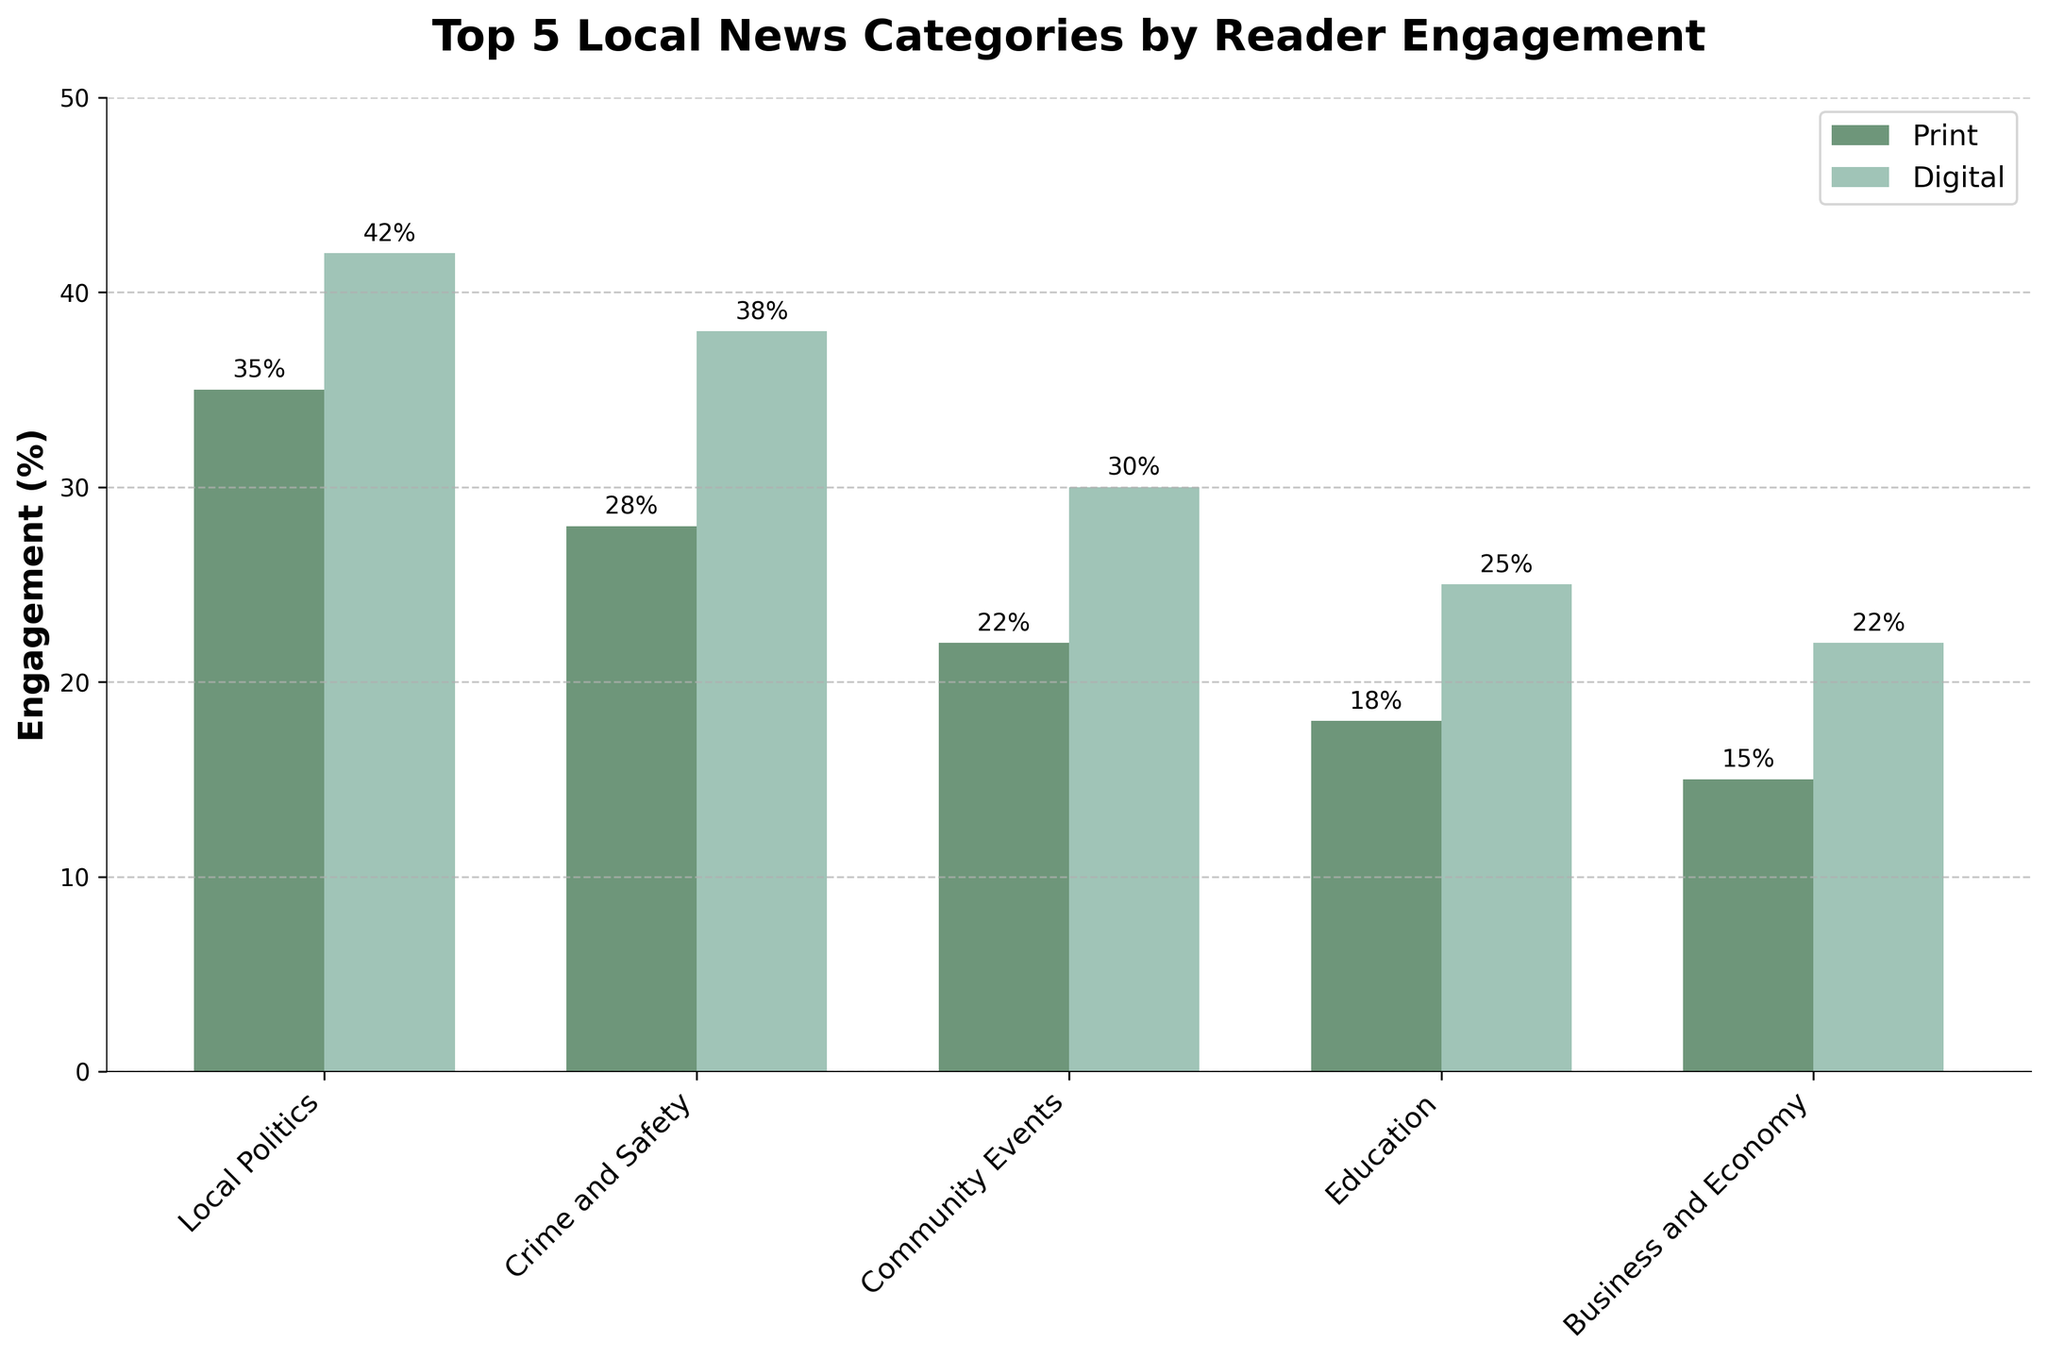Which category has the highest digital engagement? Observe the bar heights for digital engagement in each category. The highest bar corresponds to Local Politics.
Answer: Local Politics How much higher is digital engagement in Crime and Safety compared to Business and Economy? Compare the digital engagement percentages: Crime and Safety is at 38%, and Business and Economy is at 22%. The difference is 38% - 22% = 16%.
Answer: 16% What is the total engagement percentage for Print across all categories? Sum the percentages for print engagement: 35% (Local Politics) + 28% (Crime and Safety) + 22% (Community Events) + 18% (Education) + 15% (Business and Economy) = 118%.
Answer: 118% Which category has the smallest gap between print and digital engagement? Calculate the differences for each category: Local Politics (42% - 35% = 7%), Crime and Safety (38% - 28% = 10%), Community Events (30% - 22% = 8%), Education (25% - 18% = 7%), Business and Economy (22% - 15% = 7%). Local Politics, Education, and Business and Economy all have a gap of 7%.
Answer: Local Politics, Education, Business and Economy Is print engagement in Education higher than digital engagement in Business and Economy? Compare the print engagement in Education (18%) with digital engagement in Business and Economy (22%). Print engagement in Education is lower.
Answer: No Which category shows the largest increase from print to digital engagement? Calculate the differences for each category: Local Politics (42% - 35% = 7%), Crime and Safety (38% - 28% = 10%), Community Events (30% - 22% = 8%), Education (25% - 18% = 7%), Business and Economy (22% - 15% = 7%). The largest increase is in Crime and Safety with 10%.
Answer: Crime and Safety What is the average digital engagement percentage across all categories? Sum the digital engagement percentages: 42% + 38% + 30% + 25% + 22% = 157%. Divide by the number of categories (5). 157% / 5 = 31.4%.
Answer: 31.4% How much higher is local politics' print engagement compared to education's print engagement? Compare the print engagement: Local Politics is at 35%, and Education is at 18%. The difference is 35% - 18% = 17%.
Answer: 17% Which two categories have the closest digital engagement percentages? Compare the digital engagement percentages to find the smallest difference: 42% (Local Politics) vs. 38% (Crime and Safety) = 4%, 38% vs. 30% (Community Events) = 8%, 30% vs. 25% (Education) = 5%, 25% vs. 22% (Business and Economy) = 3%. The closest percentages are 25% and 22% (Education and Business and Economy) with a difference of 3%.
Answer: Education, Business and Economy 